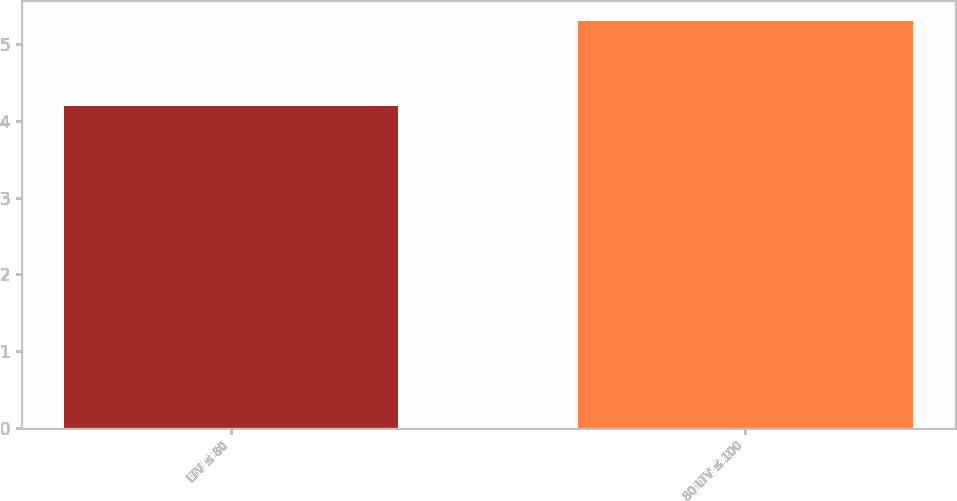Convert chart to OTSL. <chart><loc_0><loc_0><loc_500><loc_500><bar_chart><fcel>LTV ≤ 80<fcel>80 LTV ≤ 100<nl><fcel>4.2<fcel>5.3<nl></chart> 